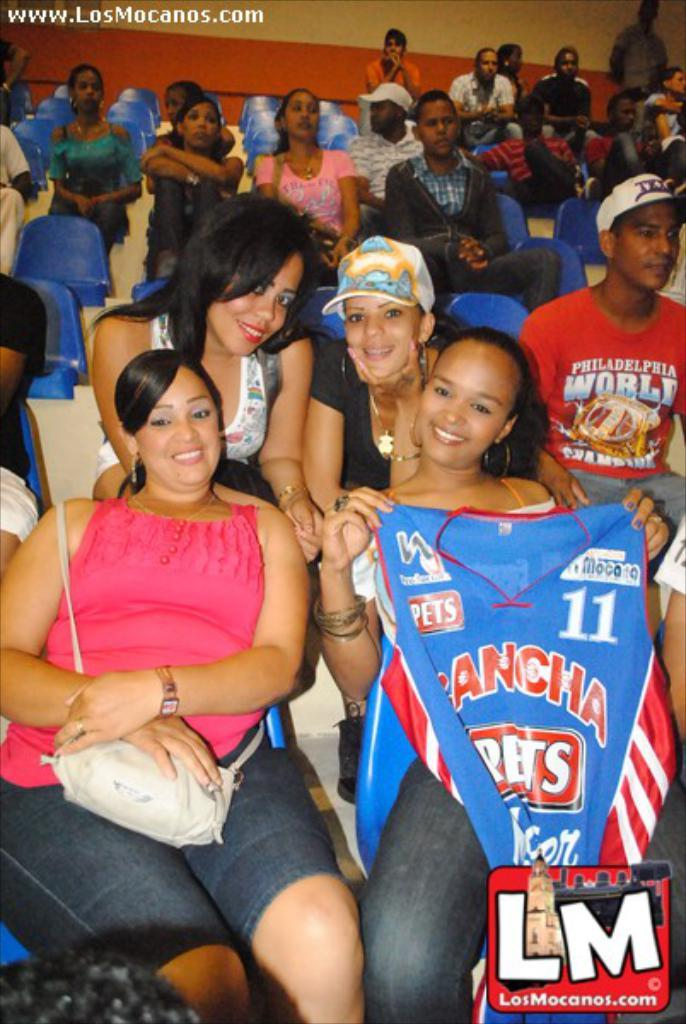<image>
Write a terse but informative summary of the picture. A crowd of spectators are sitting in the stands at a sports game and one of them is wearing a red shirt that says Philadelphia. 